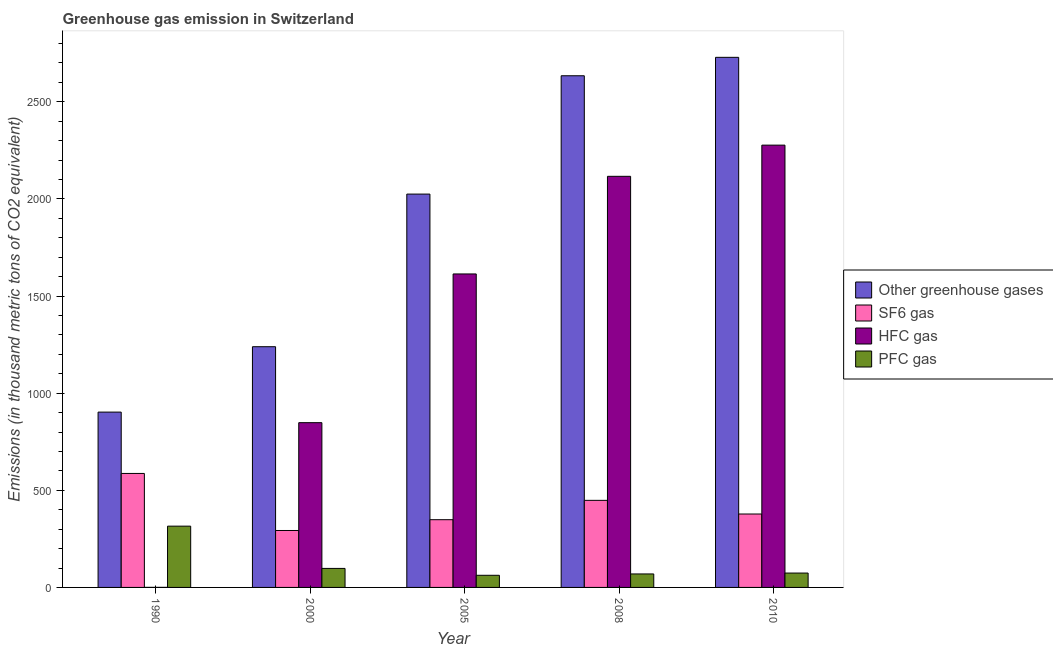Are the number of bars per tick equal to the number of legend labels?
Keep it short and to the point. Yes. Are the number of bars on each tick of the X-axis equal?
Your answer should be compact. Yes. How many bars are there on the 2nd tick from the left?
Offer a very short reply. 4. How many bars are there on the 1st tick from the right?
Your answer should be compact. 4. What is the emission of sf6 gas in 2000?
Make the answer very short. 293.1. Across all years, what is the maximum emission of pfc gas?
Provide a short and direct response. 315.5. Across all years, what is the minimum emission of sf6 gas?
Offer a very short reply. 293.1. In which year was the emission of greenhouse gases maximum?
Your answer should be compact. 2010. What is the total emission of pfc gas in the graph?
Your answer should be very brief. 619.3. What is the difference between the emission of greenhouse gases in 2005 and that in 2008?
Provide a short and direct response. -609.1. What is the difference between the emission of pfc gas in 2005 and the emission of greenhouse gases in 2000?
Give a very brief answer. -35.4. What is the average emission of hfc gas per year?
Provide a succinct answer. 1371.14. In how many years, is the emission of pfc gas greater than 1900 thousand metric tons?
Provide a short and direct response. 0. What is the ratio of the emission of pfc gas in 1990 to that in 2005?
Give a very brief answer. 5.05. Is the emission of greenhouse gases in 2000 less than that in 2008?
Provide a short and direct response. Yes. What is the difference between the highest and the second highest emission of hfc gas?
Offer a terse response. 160.6. What is the difference between the highest and the lowest emission of sf6 gas?
Your response must be concise. 293.7. In how many years, is the emission of sf6 gas greater than the average emission of sf6 gas taken over all years?
Provide a short and direct response. 2. Is it the case that in every year, the sum of the emission of greenhouse gases and emission of pfc gas is greater than the sum of emission of hfc gas and emission of sf6 gas?
Offer a terse response. Yes. What does the 3rd bar from the left in 2010 represents?
Offer a very short reply. HFC gas. What does the 3rd bar from the right in 2000 represents?
Your answer should be compact. SF6 gas. How many years are there in the graph?
Your answer should be very brief. 5. What is the difference between two consecutive major ticks on the Y-axis?
Ensure brevity in your answer.  500. Does the graph contain any zero values?
Provide a succinct answer. No. How are the legend labels stacked?
Give a very brief answer. Vertical. What is the title of the graph?
Your response must be concise. Greenhouse gas emission in Switzerland. What is the label or title of the Y-axis?
Keep it short and to the point. Emissions (in thousand metric tons of CO2 equivalent). What is the Emissions (in thousand metric tons of CO2 equivalent) in Other greenhouse gases in 1990?
Offer a very short reply. 902.6. What is the Emissions (in thousand metric tons of CO2 equivalent) of SF6 gas in 1990?
Provide a succinct answer. 586.8. What is the Emissions (in thousand metric tons of CO2 equivalent) of PFC gas in 1990?
Keep it short and to the point. 315.5. What is the Emissions (in thousand metric tons of CO2 equivalent) in Other greenhouse gases in 2000?
Offer a very short reply. 1239.2. What is the Emissions (in thousand metric tons of CO2 equivalent) of SF6 gas in 2000?
Offer a terse response. 293.1. What is the Emissions (in thousand metric tons of CO2 equivalent) in HFC gas in 2000?
Make the answer very short. 848.2. What is the Emissions (in thousand metric tons of CO2 equivalent) in PFC gas in 2000?
Offer a terse response. 97.9. What is the Emissions (in thousand metric tons of CO2 equivalent) of Other greenhouse gases in 2005?
Your response must be concise. 2025. What is the Emissions (in thousand metric tons of CO2 equivalent) of SF6 gas in 2005?
Your answer should be very brief. 348.7. What is the Emissions (in thousand metric tons of CO2 equivalent) in HFC gas in 2005?
Ensure brevity in your answer.  1613.8. What is the Emissions (in thousand metric tons of CO2 equivalent) of PFC gas in 2005?
Offer a terse response. 62.5. What is the Emissions (in thousand metric tons of CO2 equivalent) in Other greenhouse gases in 2008?
Your answer should be compact. 2634.1. What is the Emissions (in thousand metric tons of CO2 equivalent) of SF6 gas in 2008?
Your answer should be compact. 448.3. What is the Emissions (in thousand metric tons of CO2 equivalent) in HFC gas in 2008?
Ensure brevity in your answer.  2116.4. What is the Emissions (in thousand metric tons of CO2 equivalent) in PFC gas in 2008?
Provide a short and direct response. 69.4. What is the Emissions (in thousand metric tons of CO2 equivalent) in Other greenhouse gases in 2010?
Ensure brevity in your answer.  2729. What is the Emissions (in thousand metric tons of CO2 equivalent) in SF6 gas in 2010?
Your answer should be very brief. 378. What is the Emissions (in thousand metric tons of CO2 equivalent) in HFC gas in 2010?
Ensure brevity in your answer.  2277. Across all years, what is the maximum Emissions (in thousand metric tons of CO2 equivalent) of Other greenhouse gases?
Offer a very short reply. 2729. Across all years, what is the maximum Emissions (in thousand metric tons of CO2 equivalent) in SF6 gas?
Offer a very short reply. 586.8. Across all years, what is the maximum Emissions (in thousand metric tons of CO2 equivalent) of HFC gas?
Your response must be concise. 2277. Across all years, what is the maximum Emissions (in thousand metric tons of CO2 equivalent) of PFC gas?
Provide a short and direct response. 315.5. Across all years, what is the minimum Emissions (in thousand metric tons of CO2 equivalent) of Other greenhouse gases?
Give a very brief answer. 902.6. Across all years, what is the minimum Emissions (in thousand metric tons of CO2 equivalent) of SF6 gas?
Make the answer very short. 293.1. Across all years, what is the minimum Emissions (in thousand metric tons of CO2 equivalent) of PFC gas?
Your answer should be compact. 62.5. What is the total Emissions (in thousand metric tons of CO2 equivalent) of Other greenhouse gases in the graph?
Offer a very short reply. 9529.9. What is the total Emissions (in thousand metric tons of CO2 equivalent) of SF6 gas in the graph?
Your answer should be very brief. 2054.9. What is the total Emissions (in thousand metric tons of CO2 equivalent) of HFC gas in the graph?
Provide a short and direct response. 6855.7. What is the total Emissions (in thousand metric tons of CO2 equivalent) of PFC gas in the graph?
Offer a terse response. 619.3. What is the difference between the Emissions (in thousand metric tons of CO2 equivalent) in Other greenhouse gases in 1990 and that in 2000?
Offer a very short reply. -336.6. What is the difference between the Emissions (in thousand metric tons of CO2 equivalent) in SF6 gas in 1990 and that in 2000?
Ensure brevity in your answer.  293.7. What is the difference between the Emissions (in thousand metric tons of CO2 equivalent) in HFC gas in 1990 and that in 2000?
Give a very brief answer. -847.9. What is the difference between the Emissions (in thousand metric tons of CO2 equivalent) of PFC gas in 1990 and that in 2000?
Give a very brief answer. 217.6. What is the difference between the Emissions (in thousand metric tons of CO2 equivalent) of Other greenhouse gases in 1990 and that in 2005?
Your response must be concise. -1122.4. What is the difference between the Emissions (in thousand metric tons of CO2 equivalent) in SF6 gas in 1990 and that in 2005?
Keep it short and to the point. 238.1. What is the difference between the Emissions (in thousand metric tons of CO2 equivalent) of HFC gas in 1990 and that in 2005?
Provide a succinct answer. -1613.5. What is the difference between the Emissions (in thousand metric tons of CO2 equivalent) of PFC gas in 1990 and that in 2005?
Offer a very short reply. 253. What is the difference between the Emissions (in thousand metric tons of CO2 equivalent) of Other greenhouse gases in 1990 and that in 2008?
Your answer should be very brief. -1731.5. What is the difference between the Emissions (in thousand metric tons of CO2 equivalent) of SF6 gas in 1990 and that in 2008?
Keep it short and to the point. 138.5. What is the difference between the Emissions (in thousand metric tons of CO2 equivalent) in HFC gas in 1990 and that in 2008?
Keep it short and to the point. -2116.1. What is the difference between the Emissions (in thousand metric tons of CO2 equivalent) of PFC gas in 1990 and that in 2008?
Give a very brief answer. 246.1. What is the difference between the Emissions (in thousand metric tons of CO2 equivalent) of Other greenhouse gases in 1990 and that in 2010?
Offer a very short reply. -1826.4. What is the difference between the Emissions (in thousand metric tons of CO2 equivalent) of SF6 gas in 1990 and that in 2010?
Make the answer very short. 208.8. What is the difference between the Emissions (in thousand metric tons of CO2 equivalent) of HFC gas in 1990 and that in 2010?
Your answer should be very brief. -2276.7. What is the difference between the Emissions (in thousand metric tons of CO2 equivalent) in PFC gas in 1990 and that in 2010?
Your answer should be very brief. 241.5. What is the difference between the Emissions (in thousand metric tons of CO2 equivalent) of Other greenhouse gases in 2000 and that in 2005?
Your answer should be very brief. -785.8. What is the difference between the Emissions (in thousand metric tons of CO2 equivalent) of SF6 gas in 2000 and that in 2005?
Keep it short and to the point. -55.6. What is the difference between the Emissions (in thousand metric tons of CO2 equivalent) in HFC gas in 2000 and that in 2005?
Ensure brevity in your answer.  -765.6. What is the difference between the Emissions (in thousand metric tons of CO2 equivalent) in PFC gas in 2000 and that in 2005?
Ensure brevity in your answer.  35.4. What is the difference between the Emissions (in thousand metric tons of CO2 equivalent) in Other greenhouse gases in 2000 and that in 2008?
Your answer should be very brief. -1394.9. What is the difference between the Emissions (in thousand metric tons of CO2 equivalent) of SF6 gas in 2000 and that in 2008?
Offer a very short reply. -155.2. What is the difference between the Emissions (in thousand metric tons of CO2 equivalent) in HFC gas in 2000 and that in 2008?
Provide a succinct answer. -1268.2. What is the difference between the Emissions (in thousand metric tons of CO2 equivalent) of Other greenhouse gases in 2000 and that in 2010?
Make the answer very short. -1489.8. What is the difference between the Emissions (in thousand metric tons of CO2 equivalent) in SF6 gas in 2000 and that in 2010?
Give a very brief answer. -84.9. What is the difference between the Emissions (in thousand metric tons of CO2 equivalent) in HFC gas in 2000 and that in 2010?
Give a very brief answer. -1428.8. What is the difference between the Emissions (in thousand metric tons of CO2 equivalent) in PFC gas in 2000 and that in 2010?
Give a very brief answer. 23.9. What is the difference between the Emissions (in thousand metric tons of CO2 equivalent) of Other greenhouse gases in 2005 and that in 2008?
Your answer should be very brief. -609.1. What is the difference between the Emissions (in thousand metric tons of CO2 equivalent) in SF6 gas in 2005 and that in 2008?
Offer a very short reply. -99.6. What is the difference between the Emissions (in thousand metric tons of CO2 equivalent) of HFC gas in 2005 and that in 2008?
Ensure brevity in your answer.  -502.6. What is the difference between the Emissions (in thousand metric tons of CO2 equivalent) in PFC gas in 2005 and that in 2008?
Make the answer very short. -6.9. What is the difference between the Emissions (in thousand metric tons of CO2 equivalent) in Other greenhouse gases in 2005 and that in 2010?
Offer a terse response. -704. What is the difference between the Emissions (in thousand metric tons of CO2 equivalent) in SF6 gas in 2005 and that in 2010?
Keep it short and to the point. -29.3. What is the difference between the Emissions (in thousand metric tons of CO2 equivalent) in HFC gas in 2005 and that in 2010?
Give a very brief answer. -663.2. What is the difference between the Emissions (in thousand metric tons of CO2 equivalent) of Other greenhouse gases in 2008 and that in 2010?
Keep it short and to the point. -94.9. What is the difference between the Emissions (in thousand metric tons of CO2 equivalent) of SF6 gas in 2008 and that in 2010?
Make the answer very short. 70.3. What is the difference between the Emissions (in thousand metric tons of CO2 equivalent) of HFC gas in 2008 and that in 2010?
Make the answer very short. -160.6. What is the difference between the Emissions (in thousand metric tons of CO2 equivalent) of Other greenhouse gases in 1990 and the Emissions (in thousand metric tons of CO2 equivalent) of SF6 gas in 2000?
Your answer should be compact. 609.5. What is the difference between the Emissions (in thousand metric tons of CO2 equivalent) in Other greenhouse gases in 1990 and the Emissions (in thousand metric tons of CO2 equivalent) in HFC gas in 2000?
Make the answer very short. 54.4. What is the difference between the Emissions (in thousand metric tons of CO2 equivalent) in Other greenhouse gases in 1990 and the Emissions (in thousand metric tons of CO2 equivalent) in PFC gas in 2000?
Make the answer very short. 804.7. What is the difference between the Emissions (in thousand metric tons of CO2 equivalent) in SF6 gas in 1990 and the Emissions (in thousand metric tons of CO2 equivalent) in HFC gas in 2000?
Provide a short and direct response. -261.4. What is the difference between the Emissions (in thousand metric tons of CO2 equivalent) of SF6 gas in 1990 and the Emissions (in thousand metric tons of CO2 equivalent) of PFC gas in 2000?
Offer a terse response. 488.9. What is the difference between the Emissions (in thousand metric tons of CO2 equivalent) of HFC gas in 1990 and the Emissions (in thousand metric tons of CO2 equivalent) of PFC gas in 2000?
Your response must be concise. -97.6. What is the difference between the Emissions (in thousand metric tons of CO2 equivalent) of Other greenhouse gases in 1990 and the Emissions (in thousand metric tons of CO2 equivalent) of SF6 gas in 2005?
Provide a short and direct response. 553.9. What is the difference between the Emissions (in thousand metric tons of CO2 equivalent) in Other greenhouse gases in 1990 and the Emissions (in thousand metric tons of CO2 equivalent) in HFC gas in 2005?
Offer a terse response. -711.2. What is the difference between the Emissions (in thousand metric tons of CO2 equivalent) in Other greenhouse gases in 1990 and the Emissions (in thousand metric tons of CO2 equivalent) in PFC gas in 2005?
Keep it short and to the point. 840.1. What is the difference between the Emissions (in thousand metric tons of CO2 equivalent) in SF6 gas in 1990 and the Emissions (in thousand metric tons of CO2 equivalent) in HFC gas in 2005?
Keep it short and to the point. -1027. What is the difference between the Emissions (in thousand metric tons of CO2 equivalent) in SF6 gas in 1990 and the Emissions (in thousand metric tons of CO2 equivalent) in PFC gas in 2005?
Make the answer very short. 524.3. What is the difference between the Emissions (in thousand metric tons of CO2 equivalent) of HFC gas in 1990 and the Emissions (in thousand metric tons of CO2 equivalent) of PFC gas in 2005?
Provide a succinct answer. -62.2. What is the difference between the Emissions (in thousand metric tons of CO2 equivalent) in Other greenhouse gases in 1990 and the Emissions (in thousand metric tons of CO2 equivalent) in SF6 gas in 2008?
Make the answer very short. 454.3. What is the difference between the Emissions (in thousand metric tons of CO2 equivalent) in Other greenhouse gases in 1990 and the Emissions (in thousand metric tons of CO2 equivalent) in HFC gas in 2008?
Offer a terse response. -1213.8. What is the difference between the Emissions (in thousand metric tons of CO2 equivalent) in Other greenhouse gases in 1990 and the Emissions (in thousand metric tons of CO2 equivalent) in PFC gas in 2008?
Offer a terse response. 833.2. What is the difference between the Emissions (in thousand metric tons of CO2 equivalent) of SF6 gas in 1990 and the Emissions (in thousand metric tons of CO2 equivalent) of HFC gas in 2008?
Make the answer very short. -1529.6. What is the difference between the Emissions (in thousand metric tons of CO2 equivalent) in SF6 gas in 1990 and the Emissions (in thousand metric tons of CO2 equivalent) in PFC gas in 2008?
Make the answer very short. 517.4. What is the difference between the Emissions (in thousand metric tons of CO2 equivalent) in HFC gas in 1990 and the Emissions (in thousand metric tons of CO2 equivalent) in PFC gas in 2008?
Your answer should be very brief. -69.1. What is the difference between the Emissions (in thousand metric tons of CO2 equivalent) of Other greenhouse gases in 1990 and the Emissions (in thousand metric tons of CO2 equivalent) of SF6 gas in 2010?
Give a very brief answer. 524.6. What is the difference between the Emissions (in thousand metric tons of CO2 equivalent) in Other greenhouse gases in 1990 and the Emissions (in thousand metric tons of CO2 equivalent) in HFC gas in 2010?
Provide a succinct answer. -1374.4. What is the difference between the Emissions (in thousand metric tons of CO2 equivalent) of Other greenhouse gases in 1990 and the Emissions (in thousand metric tons of CO2 equivalent) of PFC gas in 2010?
Provide a short and direct response. 828.6. What is the difference between the Emissions (in thousand metric tons of CO2 equivalent) of SF6 gas in 1990 and the Emissions (in thousand metric tons of CO2 equivalent) of HFC gas in 2010?
Your answer should be compact. -1690.2. What is the difference between the Emissions (in thousand metric tons of CO2 equivalent) in SF6 gas in 1990 and the Emissions (in thousand metric tons of CO2 equivalent) in PFC gas in 2010?
Ensure brevity in your answer.  512.8. What is the difference between the Emissions (in thousand metric tons of CO2 equivalent) in HFC gas in 1990 and the Emissions (in thousand metric tons of CO2 equivalent) in PFC gas in 2010?
Provide a short and direct response. -73.7. What is the difference between the Emissions (in thousand metric tons of CO2 equivalent) of Other greenhouse gases in 2000 and the Emissions (in thousand metric tons of CO2 equivalent) of SF6 gas in 2005?
Ensure brevity in your answer.  890.5. What is the difference between the Emissions (in thousand metric tons of CO2 equivalent) of Other greenhouse gases in 2000 and the Emissions (in thousand metric tons of CO2 equivalent) of HFC gas in 2005?
Offer a very short reply. -374.6. What is the difference between the Emissions (in thousand metric tons of CO2 equivalent) in Other greenhouse gases in 2000 and the Emissions (in thousand metric tons of CO2 equivalent) in PFC gas in 2005?
Provide a succinct answer. 1176.7. What is the difference between the Emissions (in thousand metric tons of CO2 equivalent) of SF6 gas in 2000 and the Emissions (in thousand metric tons of CO2 equivalent) of HFC gas in 2005?
Give a very brief answer. -1320.7. What is the difference between the Emissions (in thousand metric tons of CO2 equivalent) of SF6 gas in 2000 and the Emissions (in thousand metric tons of CO2 equivalent) of PFC gas in 2005?
Your response must be concise. 230.6. What is the difference between the Emissions (in thousand metric tons of CO2 equivalent) in HFC gas in 2000 and the Emissions (in thousand metric tons of CO2 equivalent) in PFC gas in 2005?
Your answer should be compact. 785.7. What is the difference between the Emissions (in thousand metric tons of CO2 equivalent) in Other greenhouse gases in 2000 and the Emissions (in thousand metric tons of CO2 equivalent) in SF6 gas in 2008?
Ensure brevity in your answer.  790.9. What is the difference between the Emissions (in thousand metric tons of CO2 equivalent) of Other greenhouse gases in 2000 and the Emissions (in thousand metric tons of CO2 equivalent) of HFC gas in 2008?
Give a very brief answer. -877.2. What is the difference between the Emissions (in thousand metric tons of CO2 equivalent) of Other greenhouse gases in 2000 and the Emissions (in thousand metric tons of CO2 equivalent) of PFC gas in 2008?
Make the answer very short. 1169.8. What is the difference between the Emissions (in thousand metric tons of CO2 equivalent) of SF6 gas in 2000 and the Emissions (in thousand metric tons of CO2 equivalent) of HFC gas in 2008?
Ensure brevity in your answer.  -1823.3. What is the difference between the Emissions (in thousand metric tons of CO2 equivalent) in SF6 gas in 2000 and the Emissions (in thousand metric tons of CO2 equivalent) in PFC gas in 2008?
Your answer should be compact. 223.7. What is the difference between the Emissions (in thousand metric tons of CO2 equivalent) in HFC gas in 2000 and the Emissions (in thousand metric tons of CO2 equivalent) in PFC gas in 2008?
Keep it short and to the point. 778.8. What is the difference between the Emissions (in thousand metric tons of CO2 equivalent) of Other greenhouse gases in 2000 and the Emissions (in thousand metric tons of CO2 equivalent) of SF6 gas in 2010?
Provide a short and direct response. 861.2. What is the difference between the Emissions (in thousand metric tons of CO2 equivalent) of Other greenhouse gases in 2000 and the Emissions (in thousand metric tons of CO2 equivalent) of HFC gas in 2010?
Offer a very short reply. -1037.8. What is the difference between the Emissions (in thousand metric tons of CO2 equivalent) of Other greenhouse gases in 2000 and the Emissions (in thousand metric tons of CO2 equivalent) of PFC gas in 2010?
Give a very brief answer. 1165.2. What is the difference between the Emissions (in thousand metric tons of CO2 equivalent) of SF6 gas in 2000 and the Emissions (in thousand metric tons of CO2 equivalent) of HFC gas in 2010?
Provide a short and direct response. -1983.9. What is the difference between the Emissions (in thousand metric tons of CO2 equivalent) in SF6 gas in 2000 and the Emissions (in thousand metric tons of CO2 equivalent) in PFC gas in 2010?
Offer a very short reply. 219.1. What is the difference between the Emissions (in thousand metric tons of CO2 equivalent) in HFC gas in 2000 and the Emissions (in thousand metric tons of CO2 equivalent) in PFC gas in 2010?
Your answer should be compact. 774.2. What is the difference between the Emissions (in thousand metric tons of CO2 equivalent) of Other greenhouse gases in 2005 and the Emissions (in thousand metric tons of CO2 equivalent) of SF6 gas in 2008?
Offer a very short reply. 1576.7. What is the difference between the Emissions (in thousand metric tons of CO2 equivalent) of Other greenhouse gases in 2005 and the Emissions (in thousand metric tons of CO2 equivalent) of HFC gas in 2008?
Offer a terse response. -91.4. What is the difference between the Emissions (in thousand metric tons of CO2 equivalent) in Other greenhouse gases in 2005 and the Emissions (in thousand metric tons of CO2 equivalent) in PFC gas in 2008?
Your answer should be very brief. 1955.6. What is the difference between the Emissions (in thousand metric tons of CO2 equivalent) of SF6 gas in 2005 and the Emissions (in thousand metric tons of CO2 equivalent) of HFC gas in 2008?
Ensure brevity in your answer.  -1767.7. What is the difference between the Emissions (in thousand metric tons of CO2 equivalent) in SF6 gas in 2005 and the Emissions (in thousand metric tons of CO2 equivalent) in PFC gas in 2008?
Offer a very short reply. 279.3. What is the difference between the Emissions (in thousand metric tons of CO2 equivalent) in HFC gas in 2005 and the Emissions (in thousand metric tons of CO2 equivalent) in PFC gas in 2008?
Provide a short and direct response. 1544.4. What is the difference between the Emissions (in thousand metric tons of CO2 equivalent) in Other greenhouse gases in 2005 and the Emissions (in thousand metric tons of CO2 equivalent) in SF6 gas in 2010?
Give a very brief answer. 1647. What is the difference between the Emissions (in thousand metric tons of CO2 equivalent) of Other greenhouse gases in 2005 and the Emissions (in thousand metric tons of CO2 equivalent) of HFC gas in 2010?
Offer a very short reply. -252. What is the difference between the Emissions (in thousand metric tons of CO2 equivalent) of Other greenhouse gases in 2005 and the Emissions (in thousand metric tons of CO2 equivalent) of PFC gas in 2010?
Your answer should be very brief. 1951. What is the difference between the Emissions (in thousand metric tons of CO2 equivalent) of SF6 gas in 2005 and the Emissions (in thousand metric tons of CO2 equivalent) of HFC gas in 2010?
Ensure brevity in your answer.  -1928.3. What is the difference between the Emissions (in thousand metric tons of CO2 equivalent) in SF6 gas in 2005 and the Emissions (in thousand metric tons of CO2 equivalent) in PFC gas in 2010?
Provide a succinct answer. 274.7. What is the difference between the Emissions (in thousand metric tons of CO2 equivalent) of HFC gas in 2005 and the Emissions (in thousand metric tons of CO2 equivalent) of PFC gas in 2010?
Your answer should be very brief. 1539.8. What is the difference between the Emissions (in thousand metric tons of CO2 equivalent) of Other greenhouse gases in 2008 and the Emissions (in thousand metric tons of CO2 equivalent) of SF6 gas in 2010?
Your answer should be very brief. 2256.1. What is the difference between the Emissions (in thousand metric tons of CO2 equivalent) of Other greenhouse gases in 2008 and the Emissions (in thousand metric tons of CO2 equivalent) of HFC gas in 2010?
Ensure brevity in your answer.  357.1. What is the difference between the Emissions (in thousand metric tons of CO2 equivalent) in Other greenhouse gases in 2008 and the Emissions (in thousand metric tons of CO2 equivalent) in PFC gas in 2010?
Give a very brief answer. 2560.1. What is the difference between the Emissions (in thousand metric tons of CO2 equivalent) in SF6 gas in 2008 and the Emissions (in thousand metric tons of CO2 equivalent) in HFC gas in 2010?
Make the answer very short. -1828.7. What is the difference between the Emissions (in thousand metric tons of CO2 equivalent) in SF6 gas in 2008 and the Emissions (in thousand metric tons of CO2 equivalent) in PFC gas in 2010?
Provide a succinct answer. 374.3. What is the difference between the Emissions (in thousand metric tons of CO2 equivalent) in HFC gas in 2008 and the Emissions (in thousand metric tons of CO2 equivalent) in PFC gas in 2010?
Keep it short and to the point. 2042.4. What is the average Emissions (in thousand metric tons of CO2 equivalent) of Other greenhouse gases per year?
Make the answer very short. 1905.98. What is the average Emissions (in thousand metric tons of CO2 equivalent) in SF6 gas per year?
Your response must be concise. 410.98. What is the average Emissions (in thousand metric tons of CO2 equivalent) in HFC gas per year?
Your answer should be compact. 1371.14. What is the average Emissions (in thousand metric tons of CO2 equivalent) of PFC gas per year?
Offer a very short reply. 123.86. In the year 1990, what is the difference between the Emissions (in thousand metric tons of CO2 equivalent) in Other greenhouse gases and Emissions (in thousand metric tons of CO2 equivalent) in SF6 gas?
Your answer should be compact. 315.8. In the year 1990, what is the difference between the Emissions (in thousand metric tons of CO2 equivalent) in Other greenhouse gases and Emissions (in thousand metric tons of CO2 equivalent) in HFC gas?
Provide a short and direct response. 902.3. In the year 1990, what is the difference between the Emissions (in thousand metric tons of CO2 equivalent) in Other greenhouse gases and Emissions (in thousand metric tons of CO2 equivalent) in PFC gas?
Make the answer very short. 587.1. In the year 1990, what is the difference between the Emissions (in thousand metric tons of CO2 equivalent) of SF6 gas and Emissions (in thousand metric tons of CO2 equivalent) of HFC gas?
Make the answer very short. 586.5. In the year 1990, what is the difference between the Emissions (in thousand metric tons of CO2 equivalent) in SF6 gas and Emissions (in thousand metric tons of CO2 equivalent) in PFC gas?
Make the answer very short. 271.3. In the year 1990, what is the difference between the Emissions (in thousand metric tons of CO2 equivalent) in HFC gas and Emissions (in thousand metric tons of CO2 equivalent) in PFC gas?
Make the answer very short. -315.2. In the year 2000, what is the difference between the Emissions (in thousand metric tons of CO2 equivalent) in Other greenhouse gases and Emissions (in thousand metric tons of CO2 equivalent) in SF6 gas?
Offer a terse response. 946.1. In the year 2000, what is the difference between the Emissions (in thousand metric tons of CO2 equivalent) in Other greenhouse gases and Emissions (in thousand metric tons of CO2 equivalent) in HFC gas?
Provide a succinct answer. 391. In the year 2000, what is the difference between the Emissions (in thousand metric tons of CO2 equivalent) in Other greenhouse gases and Emissions (in thousand metric tons of CO2 equivalent) in PFC gas?
Offer a very short reply. 1141.3. In the year 2000, what is the difference between the Emissions (in thousand metric tons of CO2 equivalent) of SF6 gas and Emissions (in thousand metric tons of CO2 equivalent) of HFC gas?
Provide a short and direct response. -555.1. In the year 2000, what is the difference between the Emissions (in thousand metric tons of CO2 equivalent) in SF6 gas and Emissions (in thousand metric tons of CO2 equivalent) in PFC gas?
Ensure brevity in your answer.  195.2. In the year 2000, what is the difference between the Emissions (in thousand metric tons of CO2 equivalent) in HFC gas and Emissions (in thousand metric tons of CO2 equivalent) in PFC gas?
Your response must be concise. 750.3. In the year 2005, what is the difference between the Emissions (in thousand metric tons of CO2 equivalent) in Other greenhouse gases and Emissions (in thousand metric tons of CO2 equivalent) in SF6 gas?
Offer a very short reply. 1676.3. In the year 2005, what is the difference between the Emissions (in thousand metric tons of CO2 equivalent) in Other greenhouse gases and Emissions (in thousand metric tons of CO2 equivalent) in HFC gas?
Make the answer very short. 411.2. In the year 2005, what is the difference between the Emissions (in thousand metric tons of CO2 equivalent) of Other greenhouse gases and Emissions (in thousand metric tons of CO2 equivalent) of PFC gas?
Ensure brevity in your answer.  1962.5. In the year 2005, what is the difference between the Emissions (in thousand metric tons of CO2 equivalent) of SF6 gas and Emissions (in thousand metric tons of CO2 equivalent) of HFC gas?
Offer a terse response. -1265.1. In the year 2005, what is the difference between the Emissions (in thousand metric tons of CO2 equivalent) of SF6 gas and Emissions (in thousand metric tons of CO2 equivalent) of PFC gas?
Give a very brief answer. 286.2. In the year 2005, what is the difference between the Emissions (in thousand metric tons of CO2 equivalent) in HFC gas and Emissions (in thousand metric tons of CO2 equivalent) in PFC gas?
Offer a terse response. 1551.3. In the year 2008, what is the difference between the Emissions (in thousand metric tons of CO2 equivalent) in Other greenhouse gases and Emissions (in thousand metric tons of CO2 equivalent) in SF6 gas?
Make the answer very short. 2185.8. In the year 2008, what is the difference between the Emissions (in thousand metric tons of CO2 equivalent) of Other greenhouse gases and Emissions (in thousand metric tons of CO2 equivalent) of HFC gas?
Your response must be concise. 517.7. In the year 2008, what is the difference between the Emissions (in thousand metric tons of CO2 equivalent) in Other greenhouse gases and Emissions (in thousand metric tons of CO2 equivalent) in PFC gas?
Provide a short and direct response. 2564.7. In the year 2008, what is the difference between the Emissions (in thousand metric tons of CO2 equivalent) of SF6 gas and Emissions (in thousand metric tons of CO2 equivalent) of HFC gas?
Provide a short and direct response. -1668.1. In the year 2008, what is the difference between the Emissions (in thousand metric tons of CO2 equivalent) of SF6 gas and Emissions (in thousand metric tons of CO2 equivalent) of PFC gas?
Provide a short and direct response. 378.9. In the year 2008, what is the difference between the Emissions (in thousand metric tons of CO2 equivalent) of HFC gas and Emissions (in thousand metric tons of CO2 equivalent) of PFC gas?
Ensure brevity in your answer.  2047. In the year 2010, what is the difference between the Emissions (in thousand metric tons of CO2 equivalent) in Other greenhouse gases and Emissions (in thousand metric tons of CO2 equivalent) in SF6 gas?
Your answer should be compact. 2351. In the year 2010, what is the difference between the Emissions (in thousand metric tons of CO2 equivalent) of Other greenhouse gases and Emissions (in thousand metric tons of CO2 equivalent) of HFC gas?
Provide a short and direct response. 452. In the year 2010, what is the difference between the Emissions (in thousand metric tons of CO2 equivalent) of Other greenhouse gases and Emissions (in thousand metric tons of CO2 equivalent) of PFC gas?
Your answer should be very brief. 2655. In the year 2010, what is the difference between the Emissions (in thousand metric tons of CO2 equivalent) of SF6 gas and Emissions (in thousand metric tons of CO2 equivalent) of HFC gas?
Ensure brevity in your answer.  -1899. In the year 2010, what is the difference between the Emissions (in thousand metric tons of CO2 equivalent) of SF6 gas and Emissions (in thousand metric tons of CO2 equivalent) of PFC gas?
Your answer should be compact. 304. In the year 2010, what is the difference between the Emissions (in thousand metric tons of CO2 equivalent) in HFC gas and Emissions (in thousand metric tons of CO2 equivalent) in PFC gas?
Offer a terse response. 2203. What is the ratio of the Emissions (in thousand metric tons of CO2 equivalent) of Other greenhouse gases in 1990 to that in 2000?
Make the answer very short. 0.73. What is the ratio of the Emissions (in thousand metric tons of CO2 equivalent) in SF6 gas in 1990 to that in 2000?
Keep it short and to the point. 2. What is the ratio of the Emissions (in thousand metric tons of CO2 equivalent) of HFC gas in 1990 to that in 2000?
Make the answer very short. 0. What is the ratio of the Emissions (in thousand metric tons of CO2 equivalent) in PFC gas in 1990 to that in 2000?
Provide a short and direct response. 3.22. What is the ratio of the Emissions (in thousand metric tons of CO2 equivalent) in Other greenhouse gases in 1990 to that in 2005?
Provide a succinct answer. 0.45. What is the ratio of the Emissions (in thousand metric tons of CO2 equivalent) in SF6 gas in 1990 to that in 2005?
Provide a short and direct response. 1.68. What is the ratio of the Emissions (in thousand metric tons of CO2 equivalent) in HFC gas in 1990 to that in 2005?
Offer a very short reply. 0. What is the ratio of the Emissions (in thousand metric tons of CO2 equivalent) in PFC gas in 1990 to that in 2005?
Your response must be concise. 5.05. What is the ratio of the Emissions (in thousand metric tons of CO2 equivalent) of Other greenhouse gases in 1990 to that in 2008?
Provide a short and direct response. 0.34. What is the ratio of the Emissions (in thousand metric tons of CO2 equivalent) of SF6 gas in 1990 to that in 2008?
Offer a terse response. 1.31. What is the ratio of the Emissions (in thousand metric tons of CO2 equivalent) of HFC gas in 1990 to that in 2008?
Your response must be concise. 0. What is the ratio of the Emissions (in thousand metric tons of CO2 equivalent) of PFC gas in 1990 to that in 2008?
Keep it short and to the point. 4.55. What is the ratio of the Emissions (in thousand metric tons of CO2 equivalent) of Other greenhouse gases in 1990 to that in 2010?
Offer a very short reply. 0.33. What is the ratio of the Emissions (in thousand metric tons of CO2 equivalent) in SF6 gas in 1990 to that in 2010?
Provide a short and direct response. 1.55. What is the ratio of the Emissions (in thousand metric tons of CO2 equivalent) of HFC gas in 1990 to that in 2010?
Provide a short and direct response. 0. What is the ratio of the Emissions (in thousand metric tons of CO2 equivalent) in PFC gas in 1990 to that in 2010?
Make the answer very short. 4.26. What is the ratio of the Emissions (in thousand metric tons of CO2 equivalent) in Other greenhouse gases in 2000 to that in 2005?
Ensure brevity in your answer.  0.61. What is the ratio of the Emissions (in thousand metric tons of CO2 equivalent) of SF6 gas in 2000 to that in 2005?
Provide a short and direct response. 0.84. What is the ratio of the Emissions (in thousand metric tons of CO2 equivalent) in HFC gas in 2000 to that in 2005?
Keep it short and to the point. 0.53. What is the ratio of the Emissions (in thousand metric tons of CO2 equivalent) of PFC gas in 2000 to that in 2005?
Your answer should be very brief. 1.57. What is the ratio of the Emissions (in thousand metric tons of CO2 equivalent) of Other greenhouse gases in 2000 to that in 2008?
Ensure brevity in your answer.  0.47. What is the ratio of the Emissions (in thousand metric tons of CO2 equivalent) in SF6 gas in 2000 to that in 2008?
Give a very brief answer. 0.65. What is the ratio of the Emissions (in thousand metric tons of CO2 equivalent) in HFC gas in 2000 to that in 2008?
Offer a terse response. 0.4. What is the ratio of the Emissions (in thousand metric tons of CO2 equivalent) of PFC gas in 2000 to that in 2008?
Your answer should be compact. 1.41. What is the ratio of the Emissions (in thousand metric tons of CO2 equivalent) of Other greenhouse gases in 2000 to that in 2010?
Offer a very short reply. 0.45. What is the ratio of the Emissions (in thousand metric tons of CO2 equivalent) in SF6 gas in 2000 to that in 2010?
Provide a succinct answer. 0.78. What is the ratio of the Emissions (in thousand metric tons of CO2 equivalent) of HFC gas in 2000 to that in 2010?
Your answer should be very brief. 0.37. What is the ratio of the Emissions (in thousand metric tons of CO2 equivalent) in PFC gas in 2000 to that in 2010?
Offer a very short reply. 1.32. What is the ratio of the Emissions (in thousand metric tons of CO2 equivalent) of Other greenhouse gases in 2005 to that in 2008?
Your response must be concise. 0.77. What is the ratio of the Emissions (in thousand metric tons of CO2 equivalent) in SF6 gas in 2005 to that in 2008?
Provide a short and direct response. 0.78. What is the ratio of the Emissions (in thousand metric tons of CO2 equivalent) of HFC gas in 2005 to that in 2008?
Provide a succinct answer. 0.76. What is the ratio of the Emissions (in thousand metric tons of CO2 equivalent) in PFC gas in 2005 to that in 2008?
Your response must be concise. 0.9. What is the ratio of the Emissions (in thousand metric tons of CO2 equivalent) of Other greenhouse gases in 2005 to that in 2010?
Make the answer very short. 0.74. What is the ratio of the Emissions (in thousand metric tons of CO2 equivalent) of SF6 gas in 2005 to that in 2010?
Make the answer very short. 0.92. What is the ratio of the Emissions (in thousand metric tons of CO2 equivalent) of HFC gas in 2005 to that in 2010?
Ensure brevity in your answer.  0.71. What is the ratio of the Emissions (in thousand metric tons of CO2 equivalent) of PFC gas in 2005 to that in 2010?
Offer a very short reply. 0.84. What is the ratio of the Emissions (in thousand metric tons of CO2 equivalent) of Other greenhouse gases in 2008 to that in 2010?
Provide a succinct answer. 0.97. What is the ratio of the Emissions (in thousand metric tons of CO2 equivalent) of SF6 gas in 2008 to that in 2010?
Provide a succinct answer. 1.19. What is the ratio of the Emissions (in thousand metric tons of CO2 equivalent) in HFC gas in 2008 to that in 2010?
Make the answer very short. 0.93. What is the ratio of the Emissions (in thousand metric tons of CO2 equivalent) in PFC gas in 2008 to that in 2010?
Offer a very short reply. 0.94. What is the difference between the highest and the second highest Emissions (in thousand metric tons of CO2 equivalent) of Other greenhouse gases?
Your response must be concise. 94.9. What is the difference between the highest and the second highest Emissions (in thousand metric tons of CO2 equivalent) of SF6 gas?
Offer a terse response. 138.5. What is the difference between the highest and the second highest Emissions (in thousand metric tons of CO2 equivalent) in HFC gas?
Provide a succinct answer. 160.6. What is the difference between the highest and the second highest Emissions (in thousand metric tons of CO2 equivalent) of PFC gas?
Give a very brief answer. 217.6. What is the difference between the highest and the lowest Emissions (in thousand metric tons of CO2 equivalent) in Other greenhouse gases?
Provide a short and direct response. 1826.4. What is the difference between the highest and the lowest Emissions (in thousand metric tons of CO2 equivalent) of SF6 gas?
Provide a short and direct response. 293.7. What is the difference between the highest and the lowest Emissions (in thousand metric tons of CO2 equivalent) of HFC gas?
Your response must be concise. 2276.7. What is the difference between the highest and the lowest Emissions (in thousand metric tons of CO2 equivalent) in PFC gas?
Your answer should be compact. 253. 